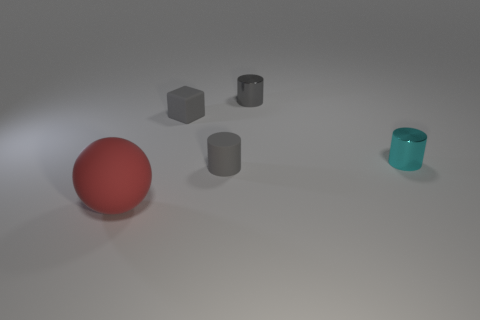Add 4 small red cubes. How many objects exist? 9 Subtract all spheres. How many objects are left? 4 Add 4 matte balls. How many matte balls exist? 5 Subtract 0 green blocks. How many objects are left? 5 Subtract all yellow shiny balls. Subtract all matte things. How many objects are left? 2 Add 5 small gray rubber cylinders. How many small gray rubber cylinders are left? 6 